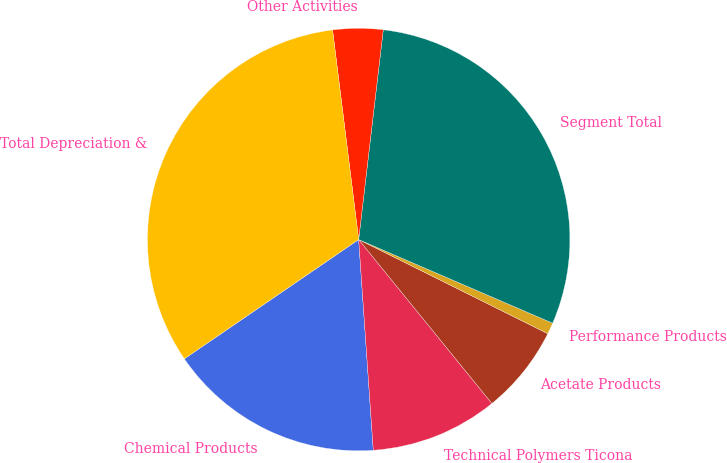<chart> <loc_0><loc_0><loc_500><loc_500><pie_chart><fcel>Chemical Products<fcel>Technical Polymers Ticona<fcel>Acetate Products<fcel>Performance Products<fcel>Segment Total<fcel>Other Activities<fcel>Total Depreciation &<nl><fcel>16.55%<fcel>9.76%<fcel>6.79%<fcel>0.87%<fcel>29.62%<fcel>3.83%<fcel>32.58%<nl></chart> 